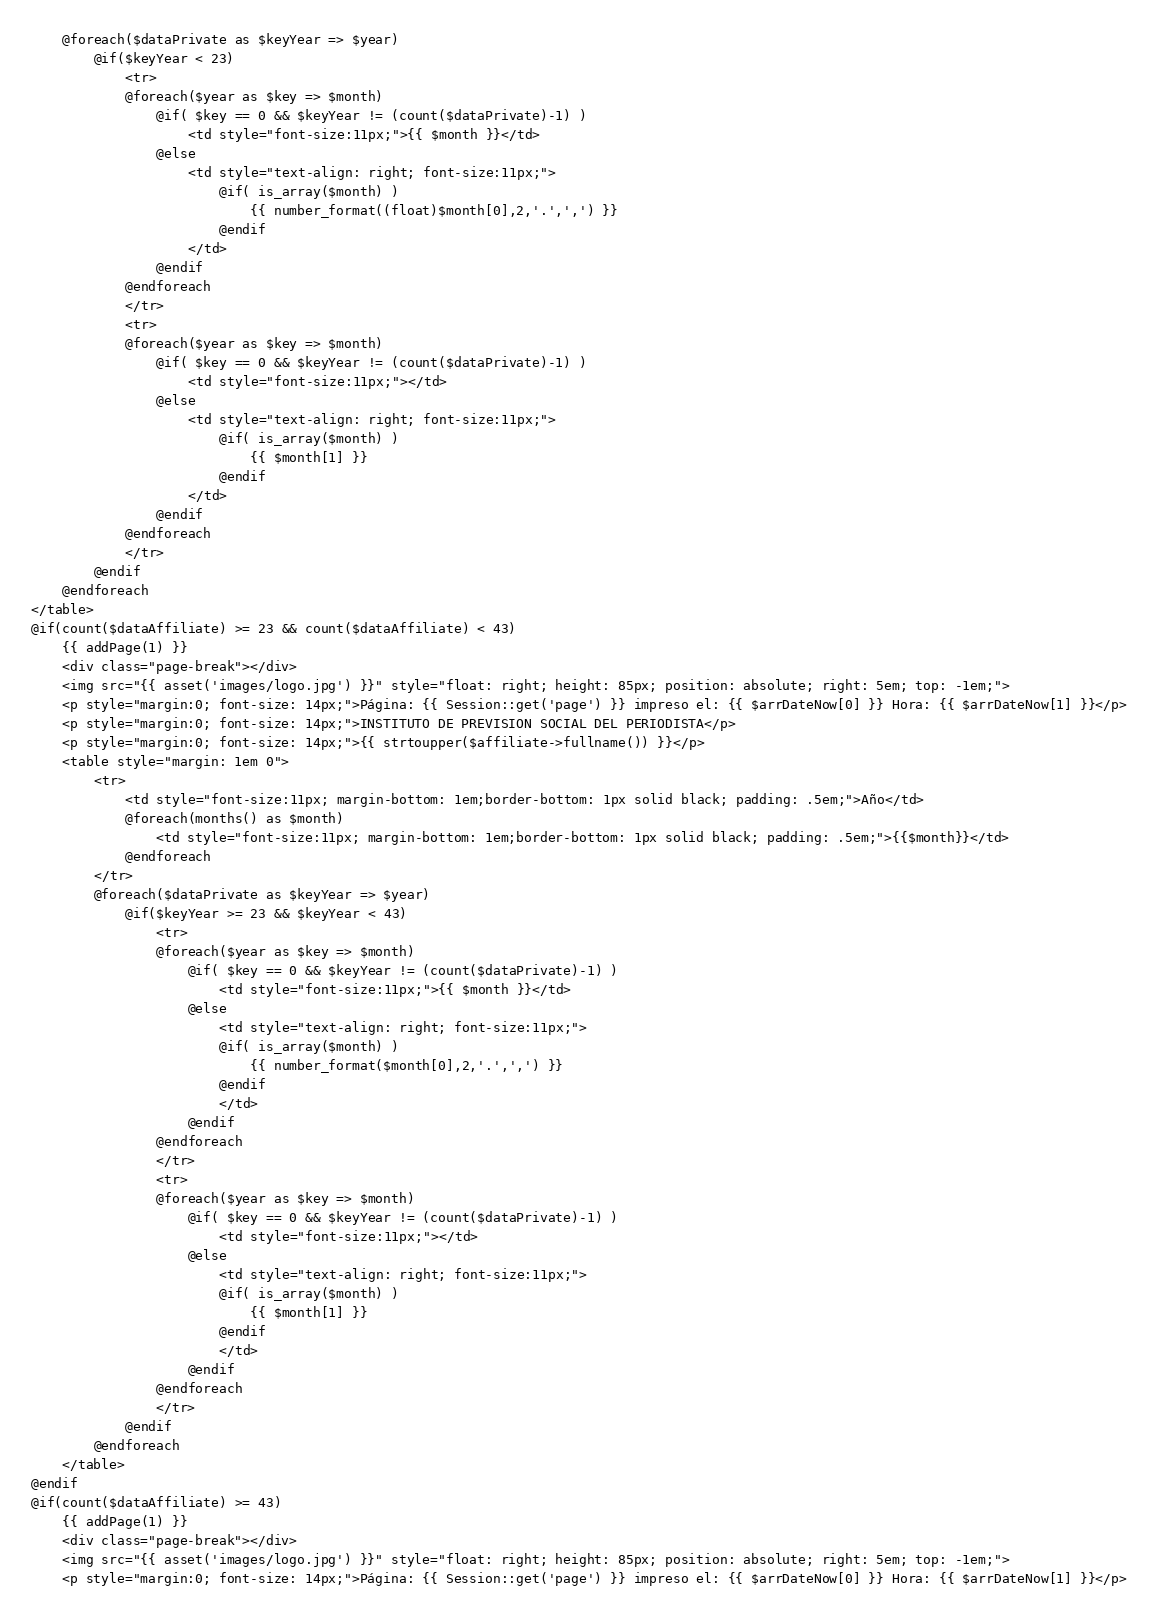Convert code to text. <code><loc_0><loc_0><loc_500><loc_500><_PHP_>	@foreach($dataPrivate as $keyYear => $year)
		@if($keyYear < 23)
			<tr>
			@foreach($year as $key => $month)
				@if( $key == 0 && $keyYear != (count($dataPrivate)-1) )
					<td style="font-size:11px;">{{ $month }}</td>
				@else
					<td style="text-align: right; font-size:11px;">
						@if( is_array($month) )
							{{ number_format((float)$month[0],2,'.',',') }}
						@endif
					</td>
				@endif
			@endforeach
			</tr>
			<tr>
			@foreach($year as $key => $month)
				@if( $key == 0 && $keyYear != (count($dataPrivate)-1) )
					<td style="font-size:11px;"></td>
				@else
					<td style="text-align: right; font-size:11px;">
						@if( is_array($month) )
							{{ $month[1] }}
						@endif
					</td>
				@endif
			@endforeach
			</tr>
		@endif
	@endforeach
</table>
@if(count($dataAffiliate) >= 23 && count($dataAffiliate) < 43)
	{{ addPage(1) }}
	<div class="page-break"></div>
	<img src="{{ asset('images/logo.jpg') }}" style="float: right; height: 85px; position: absolute; right: 5em; top: -1em;">
	<p style="margin:0; font-size: 14px;">Página: {{ Session::get('page') }} impreso el: {{ $arrDateNow[0] }} Hora: {{ $arrDateNow[1] }}</p>
	<p style="margin:0; font-size: 14px;">INSTITUTO DE PREVISION SOCIAL DEL PERIODISTA</p>
	<p style="margin:0; font-size: 14px;">{{ strtoupper($affiliate->fullname()) }}</p>
	<table style="margin: 1em 0">
		<tr>
			<td style="font-size:11px; margin-bottom: 1em;border-bottom: 1px solid black; padding: .5em;">Año</td>
			@foreach(months() as $month)
				<td style="font-size:11px; margin-bottom: 1em;border-bottom: 1px solid black; padding: .5em;">{{$month}}</td>
			@endforeach
		</tr>
		@foreach($dataPrivate as $keyYear => $year)
			@if($keyYear >= 23 && $keyYear < 43)
				<tr>
				@foreach($year as $key => $month)
					@if( $key == 0 && $keyYear != (count($dataPrivate)-1) )
						<td style="font-size:11px;">{{ $month }}</td>
					@else
						<td style="text-align: right; font-size:11px;">
						@if( is_array($month) )
							{{ number_format($month[0],2,'.',',') }}
						@endif
						</td>
					@endif
				@endforeach
				</tr>
				<tr>
				@foreach($year as $key => $month)
					@if( $key == 0 && $keyYear != (count($dataPrivate)-1) )
						<td style="font-size:11px;"></td>
					@else
						<td style="text-align: right; font-size:11px;">
						@if( is_array($month) )
							{{ $month[1] }}
						@endif
						</td>
					@endif
				@endforeach
				</tr>
			@endif
		@endforeach
	</table>
@endif
@if(count($dataAffiliate) >= 43)
	{{ addPage(1) }}
	<div class="page-break"></div>
	<img src="{{ asset('images/logo.jpg') }}" style="float: right; height: 85px; position: absolute; right: 5em; top: -1em;">
	<p style="margin:0; font-size: 14px;">Página: {{ Session::get('page') }} impreso el: {{ $arrDateNow[0] }} Hora: {{ $arrDateNow[1] }}</p></code> 